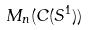Convert formula to latex. <formula><loc_0><loc_0><loc_500><loc_500>M _ { n } ( C ( S ^ { 1 } ) )</formula> 